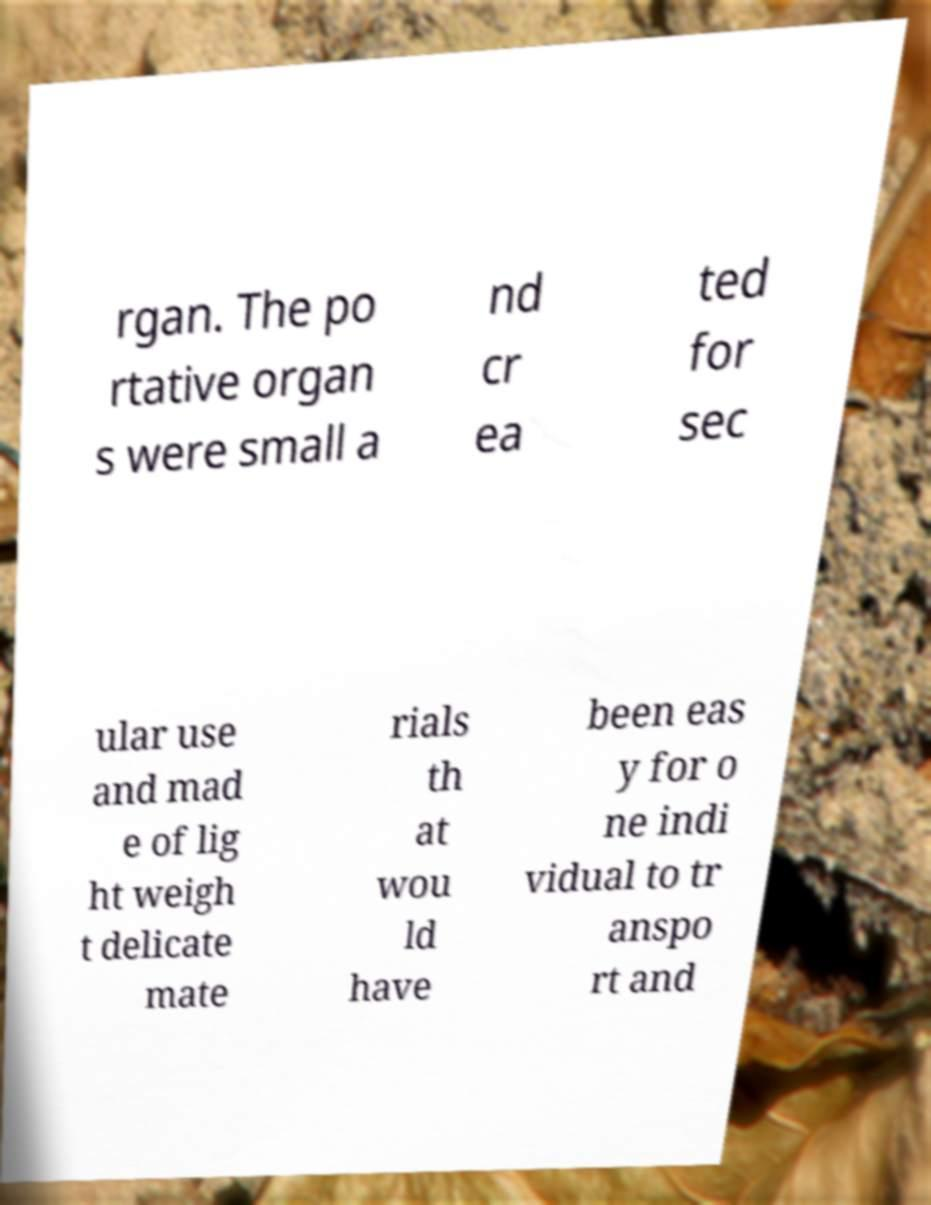For documentation purposes, I need the text within this image transcribed. Could you provide that? rgan. The po rtative organ s were small a nd cr ea ted for sec ular use and mad e of lig ht weigh t delicate mate rials th at wou ld have been eas y for o ne indi vidual to tr anspo rt and 